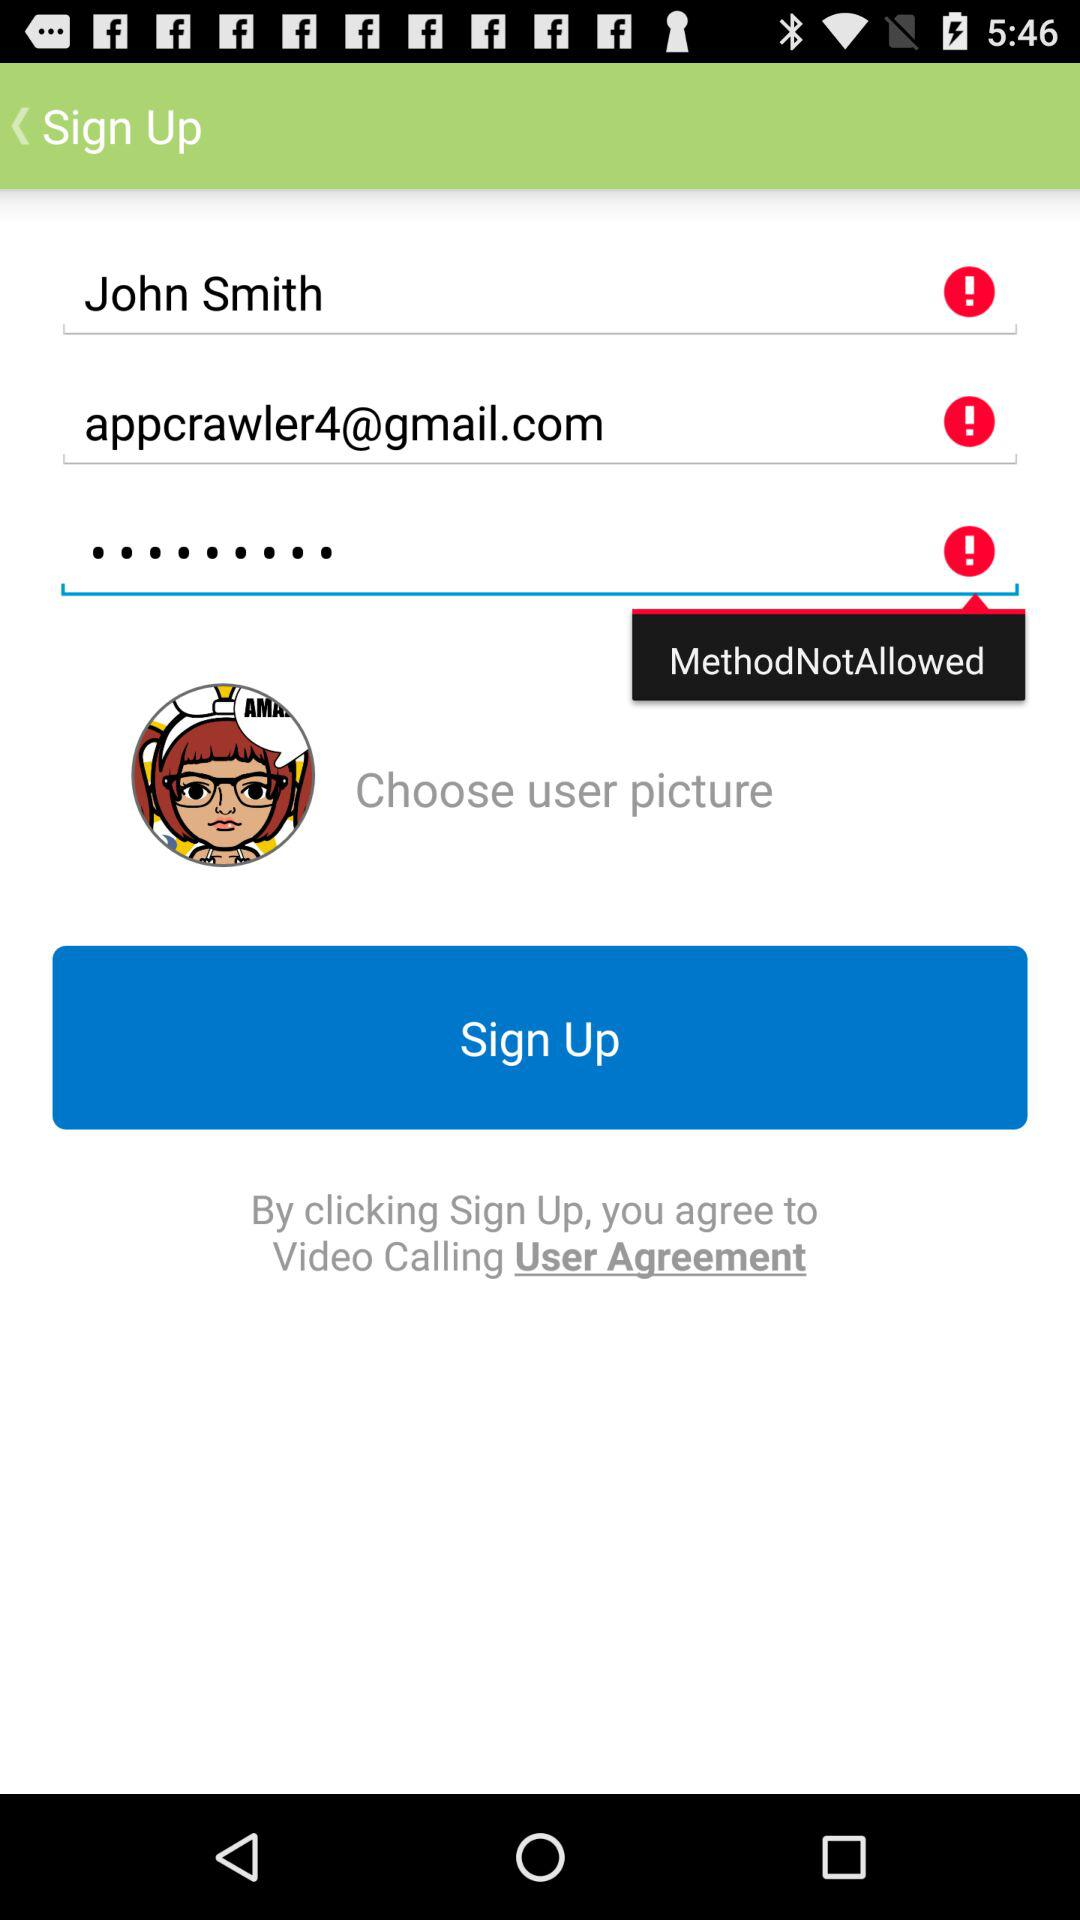What is the name of the application? The name of the application is "Video Calling". 